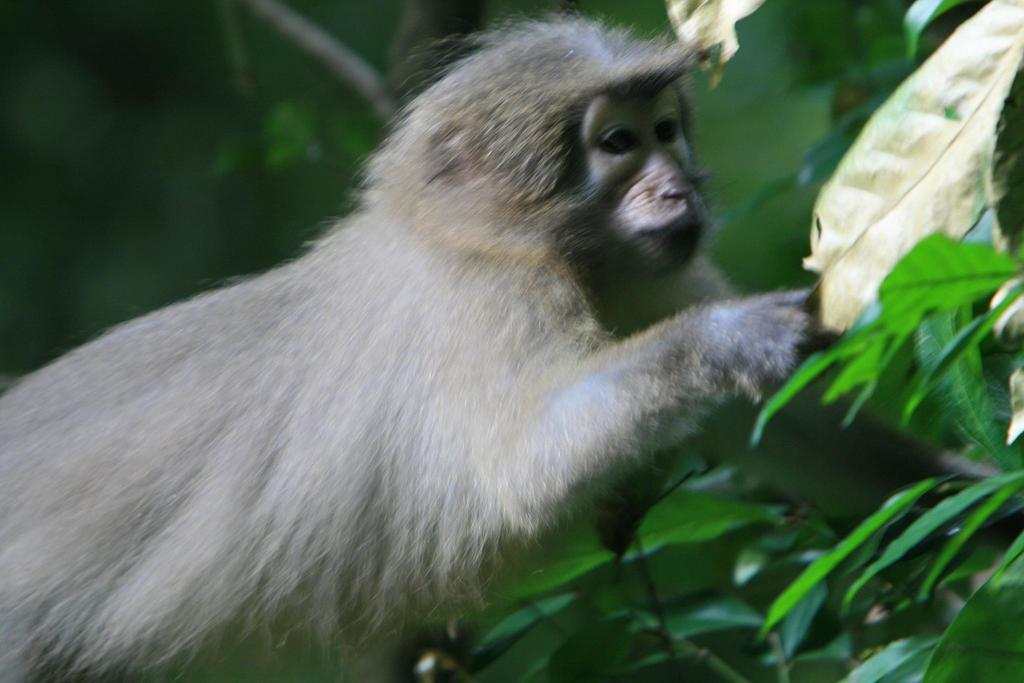What animal is present in the image? There is a monkey in the image. What type of vegetation can be seen in the image? There are leaves in the image. Can you describe the background of the image? The background of the image is blurry. What type of salt can be seen on the trail in the image? There is no trail or salt present in the image; it features a monkey and leaves with a blurry background. 